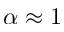Convert formula to latex. <formula><loc_0><loc_0><loc_500><loc_500>\alpha \approx 1</formula> 